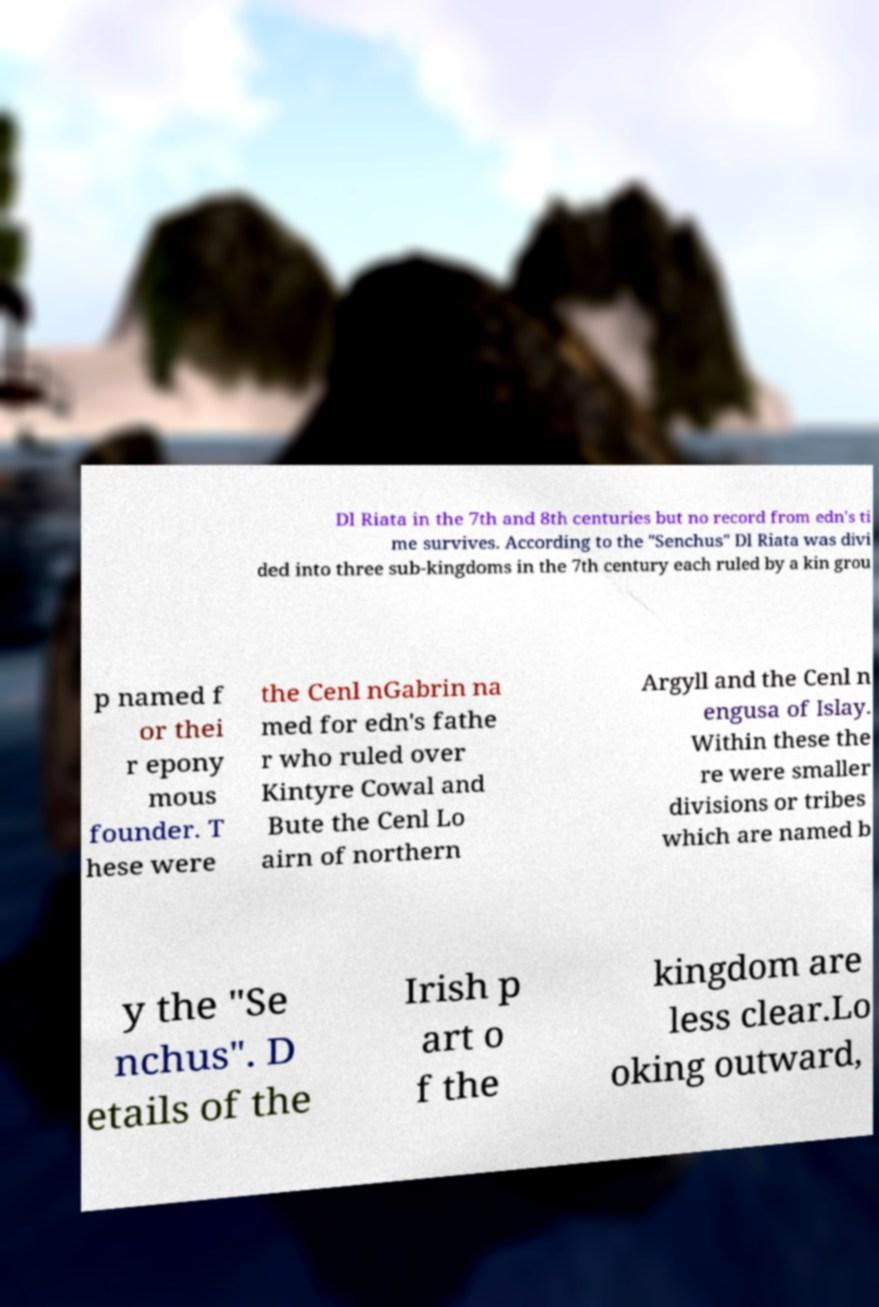Please read and relay the text visible in this image. What does it say? Dl Riata in the 7th and 8th centuries but no record from edn's ti me survives. According to the "Senchus" Dl Riata was divi ded into three sub-kingdoms in the 7th century each ruled by a kin grou p named f or thei r epony mous founder. T hese were the Cenl nGabrin na med for edn's fathe r who ruled over Kintyre Cowal and Bute the Cenl Lo airn of northern Argyll and the Cenl n engusa of Islay. Within these the re were smaller divisions or tribes which are named b y the "Se nchus". D etails of the Irish p art o f the kingdom are less clear.Lo oking outward, 